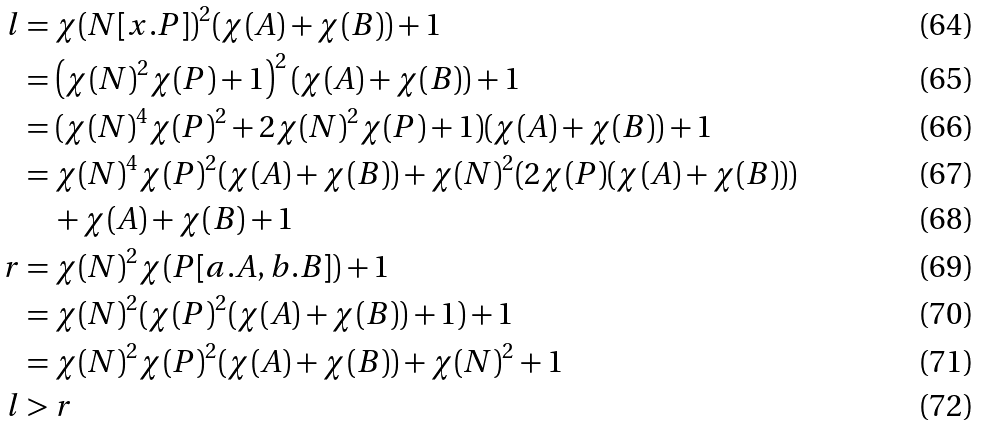<formula> <loc_0><loc_0><loc_500><loc_500>l & = \chi ( N [ x . P ] ) ^ { 2 } ( \chi ( A ) + \chi ( B ) ) + 1 \\ & = \left ( \chi ( N ) ^ { 2 } \chi ( P ) + 1 \right ) ^ { 2 } ( \chi ( A ) + \chi ( B ) ) + 1 \\ & = ( \chi ( N ) ^ { 4 } \chi ( P ) ^ { 2 } + 2 \chi ( N ) ^ { 2 } \chi ( P ) + 1 ) ( \chi ( A ) + \chi ( B ) ) + 1 \\ & = \chi ( N ) ^ { 4 } \chi ( P ) ^ { 2 } ( \chi ( A ) + \chi ( B ) ) + \chi ( N ) ^ { 2 } ( 2 \chi ( P ) ( \chi ( A ) + \chi ( B ) ) ) \\ & \quad + \chi ( A ) + \chi ( B ) + 1 \\ r & = \chi ( N ) ^ { 2 } \chi ( P [ a . A , b . B ] ) + 1 \\ & = \chi ( N ) ^ { 2 } ( \chi ( P ) ^ { 2 } ( \chi ( A ) + \chi ( B ) ) + 1 ) + 1 \\ & = \chi ( N ) ^ { 2 } \chi ( P ) ^ { 2 } ( \chi ( A ) + \chi ( B ) ) + \chi ( N ) ^ { 2 } + 1 \\ l & > r</formula> 